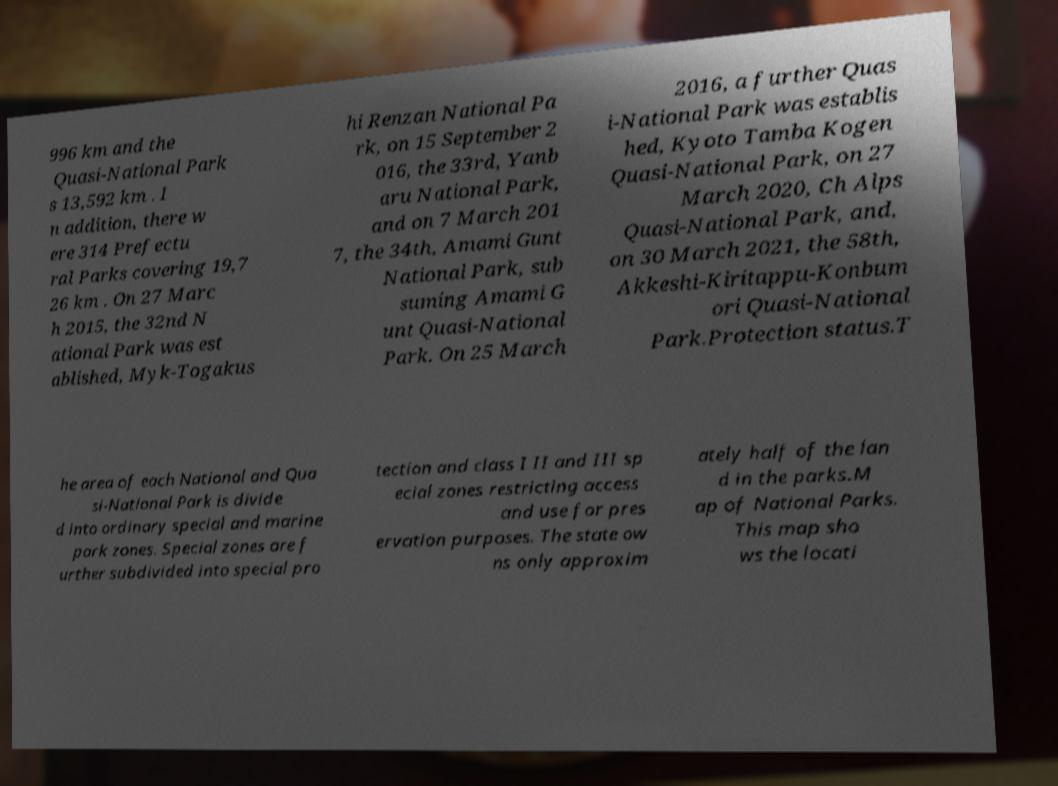Please read and relay the text visible in this image. What does it say? 996 km and the Quasi-National Park s 13,592 km . I n addition, there w ere 314 Prefectu ral Parks covering 19,7 26 km . On 27 Marc h 2015, the 32nd N ational Park was est ablished, Myk-Togakus hi Renzan National Pa rk, on 15 September 2 016, the 33rd, Yanb aru National Park, and on 7 March 201 7, the 34th, Amami Gunt National Park, sub suming Amami G unt Quasi-National Park. On 25 March 2016, a further Quas i-National Park was establis hed, Kyoto Tamba Kogen Quasi-National Park, on 27 March 2020, Ch Alps Quasi-National Park, and, on 30 March 2021, the 58th, Akkeshi-Kiritappu-Konbum ori Quasi-National Park.Protection status.T he area of each National and Qua si-National Park is divide d into ordinary special and marine park zones. Special zones are f urther subdivided into special pro tection and class I II and III sp ecial zones restricting access and use for pres ervation purposes. The state ow ns only approxim ately half of the lan d in the parks.M ap of National Parks. This map sho ws the locati 